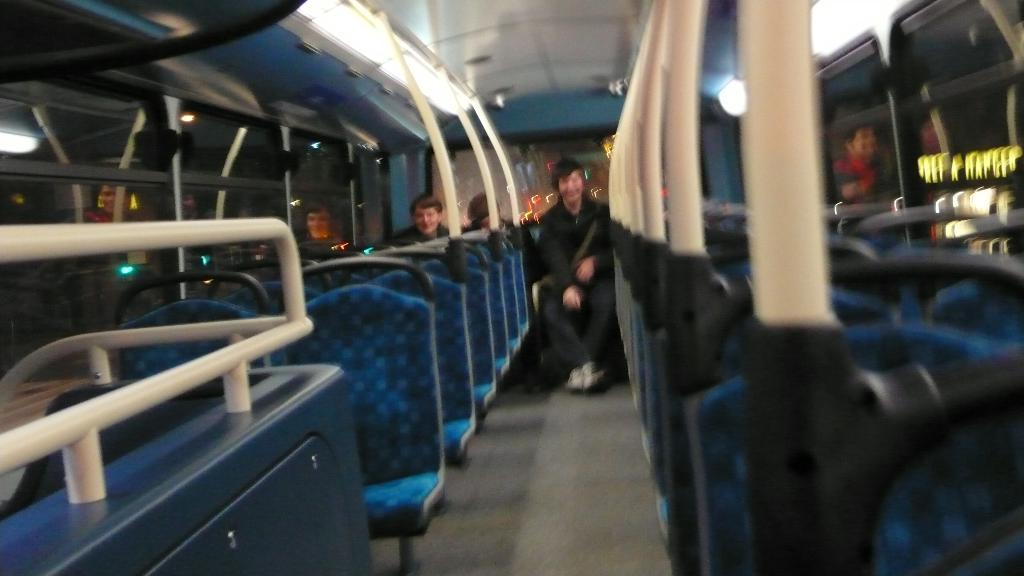What type of location is depicted in the image? The image is an inside view of a vehicle. How many people are present in the vehicle? There are three persons sitting on the seats in the vehicle. What can be seen in the image besides the people? There are lights visible in the image. What features are present in the vehicle to provide comfort and visibility? There are seats and windows in the vehicle. What type of letters can be seen on the seats in the image? There are no letters visible on the seats in the image. What is the angle of the vehicle in the image? The angle of the vehicle cannot be determined from the image, as it is an inside view. 